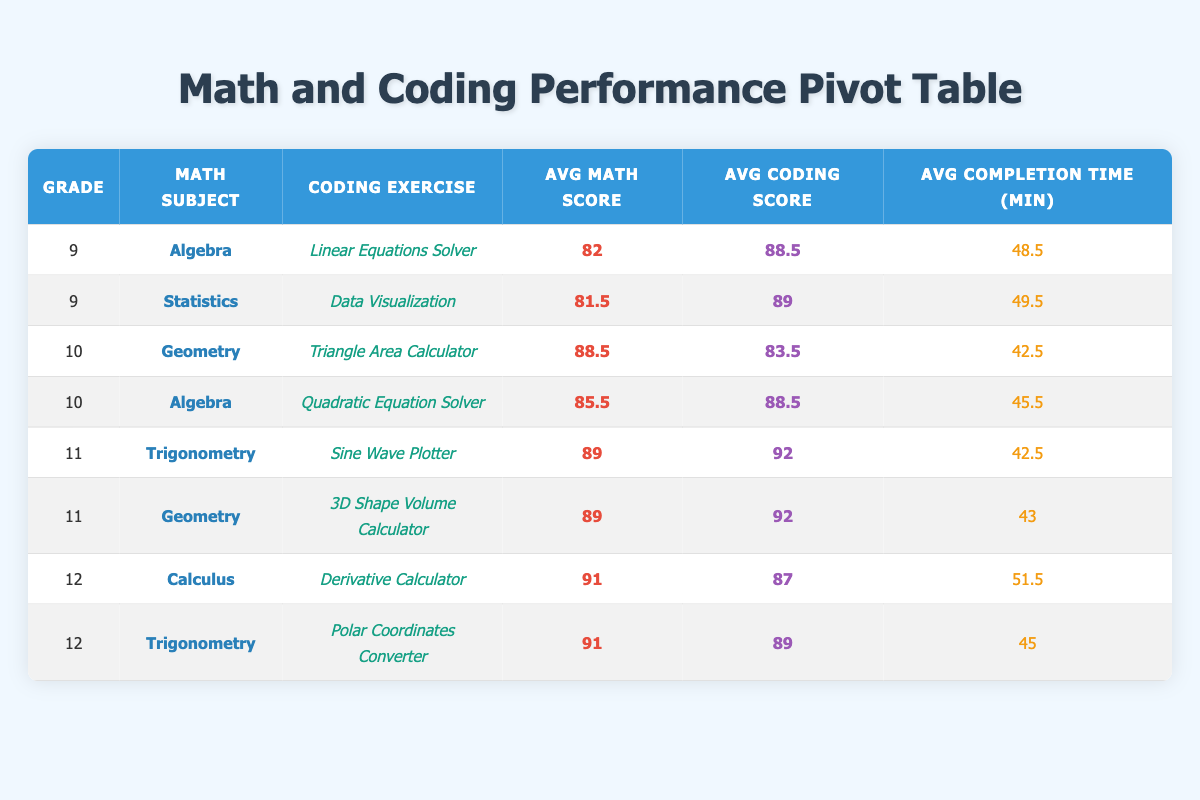What is the average math score for grade 10 students? There are four grade 10 students in the table with math scores of 95, 82, 90, and 81. To find the average, I will first sum these scores: 95 + 82 + 90 + 81 = 348. Then I will divide by the number of students, which is 4. So, 348 / 4 = 87.
Answer: 87 What is the coding exercise with the highest average coding score? The average coding scores for various exercises are: Linear Equations Solver: 88.5, Data Visualization: 89, Triangle Area Calculator: 83.5, Quadratic Equation Solver: 88.5, Sine Wave Plotter: 91, 3D Shape Volume Calculator: 92, Derivative Calculator: 87, Polar Coordinates Converter: 89. The highest average coding score is 92 for "3D Shape Volume Calculator."
Answer: 3D Shape Volume Calculator Are there any students in grade 12 who scored above 90 in math? The grade 12 students and their math scores are: Isabella Nguyen (93), Mason Taylor (89), Amelia Anderson (94), and Lucas Wright (88). Both Isabella and Amelia scored above 90 in math. Therefore, there are students in grade 12 who scored above 90.
Answer: Yes What are the average completion times for coding exercises in grade 11? The grade 11 students and their completion times are: Sine Wave Plotter: 41, 44; 3D Shape Volume Calculator: 40, 46. The total completion time is 41 + 44 + 40 + 46 = 171 minutes and the average is 171 / 4 = 42.75.
Answer: 42.75 Is the average math score for "Algebra" higher than that for "Trigonometry"? The average math score for "Algebra" is (88 + 76 + 90 + 81) / 4 = 83.75. The average for "Trigonometry" is (91 + 87 + 94 + 88) / 4 = 90. So, 83.75 is not higher than 90.
Answer: No What is the difference between the highest and lowest average coding scores by grade? The highest average coding score is 92 (11th grade), and the lowest average coding score is 83.5 (10th grade for Triangle Area Calculator). Therefore, the difference is 92 - 83.5 = 8.5.
Answer: 8.5 Which math subject has the highest average math score across all grades? The average math scores for subjects are: Algebra: (88 + 76 + 90 + 81) / 4 = 83.75; Geometry: (95 + 82 + 92 + 86) / 4 = 88.75; Trigonometry: (91 + 87 + 94 + 88) / 4 = 90; Calculus: (93 + 89) / 2 = 91. The highest average is for Calculus at 91.
Answer: Calculus What was the average completion time across all students? To find the average completion time, I will sum all completion times: 45 + 52 + 38 + 47 + 41 + 44 + 50 + 53 + 48 + 51 + 42 + 49 + 40 + 46 + 43 + 47 = 708. Then, there are 16 students, so the average completion time is 708 / 16 = 44.25.
Answer: 44.25 